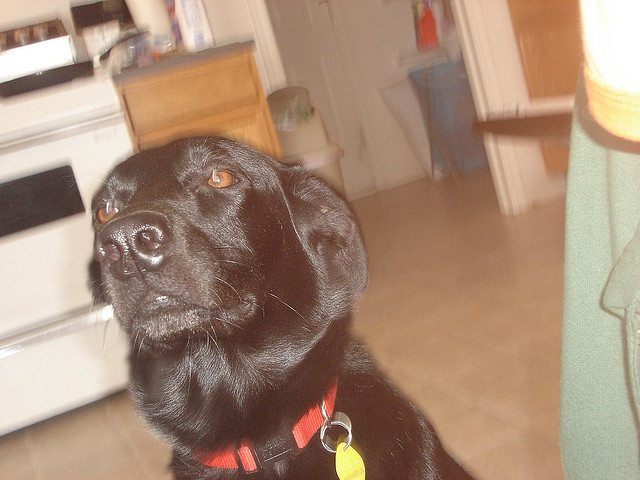Describe the objects in this image and their specific colors. I can see dog in tan, maroon, and gray tones, oven in tan, ivory, black, and lightgray tones, and people in tan, beige, darkgray, ivory, and lightgray tones in this image. 